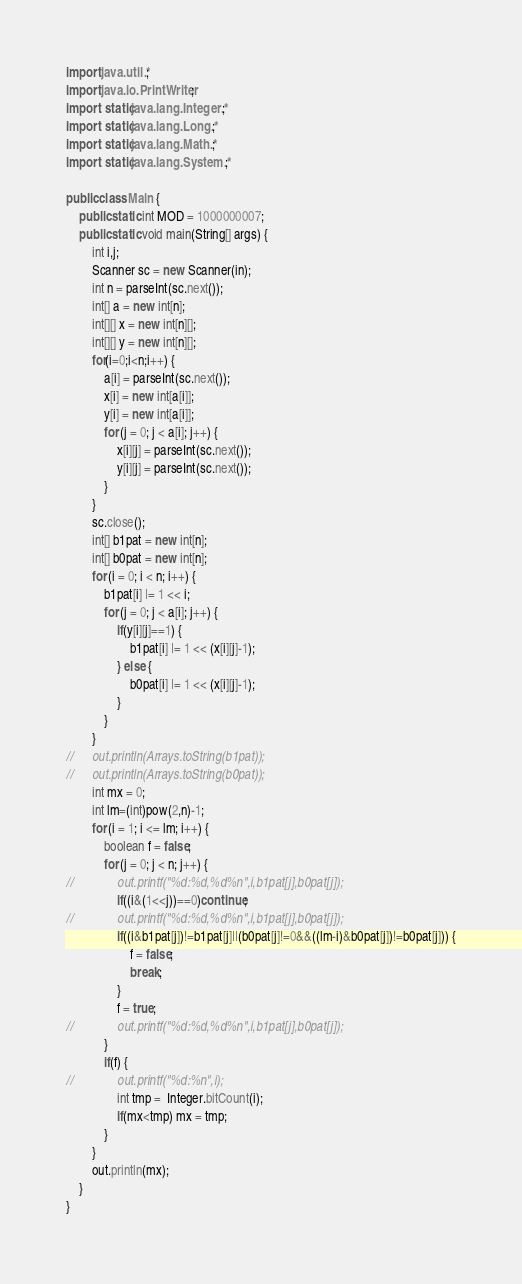Convert code to text. <code><loc_0><loc_0><loc_500><loc_500><_Java_>import java.util.*;
import java.io.PrintWriter;
import static java.lang.Integer.*;
import static java.lang.Long.*;
import static java.lang.Math.*;
import static java.lang.System.*;

public class Main {
	public static int MOD = 1000000007;
	public static void main(String[] args) {
		int i,j;
		Scanner sc = new Scanner(in);
		int n = parseInt(sc.next());
		int[] a = new int[n];
		int[][] x = new int[n][];
		int[][] y = new int[n][];
		for(i=0;i<n;i++) {
			a[i] = parseInt(sc.next());
			x[i] = new int[a[i]]; 
			y[i] = new int[a[i]]; 
			for (j = 0; j < a[i]; j++) {
				x[i][j] = parseInt(sc.next());
				y[i][j] = parseInt(sc.next());
			}
		}
		sc.close();
		int[] b1pat = new int[n];
		int[] b0pat = new int[n];
		for (i = 0; i < n; i++) {
			b1pat[i] |= 1 << i;
			for (j = 0; j < a[i]; j++) {
				if(y[i][j]==1) {
					b1pat[i] |= 1 << (x[i][j]-1);
				} else {
					b0pat[i] |= 1 << (x[i][j]-1);
				}
			}
		}
//		out.println(Arrays.toString(b1pat));
//		out.println(Arrays.toString(b0pat));
		int mx = 0;
		int lm=(int)pow(2,n)-1;
		for (i = 1; i <= lm; i++) {
			boolean f = false;
			for (j = 0; j < n; j++) {
//				out.printf("%d:%d,%d%n",i,b1pat[j],b0pat[j]);
				if((i&(1<<j))==0)continue;
//				out.printf("%d:%d,%d%n",i,b1pat[j],b0pat[j]);
				if((i&b1pat[j])!=b1pat[j]||(b0pat[j]!=0&&((lm-i)&b0pat[j])!=b0pat[j])) {
					f = false;
					break;
				}
				f = true;
//				out.printf("%d:%d,%d%n",i,b1pat[j],b0pat[j]);
			}
			if(f) {
//				out.printf("%d:%n",i);
				int tmp =  Integer.bitCount(i);
				if(mx<tmp) mx = tmp; 
			}
		}
		out.println(mx);
	}
}
</code> 